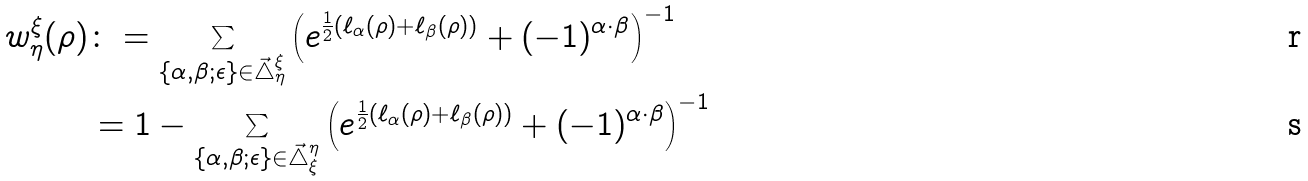<formula> <loc_0><loc_0><loc_500><loc_500>w ^ { \xi } _ { \eta } ( \rho ) & \colon = \sum _ { \{ \alpha , \beta ; \epsilon \} \in \vec { \mathcal { \triangle } } ^ { \xi } _ { \eta } } \left ( e ^ { \frac { 1 } { 2 } ( \ell _ { \alpha } ( \rho ) + \ell _ { \beta } ( \rho ) ) } + ( - 1 ) ^ { \alpha \cdot \beta } \right ) ^ { - 1 } \\ & = 1 - \sum _ { \{ \alpha , \beta ; \epsilon \} \in \vec { \mathcal { \triangle } } ^ { \eta } _ { \xi } } \left ( e ^ { \frac { 1 } { 2 } ( \ell _ { \alpha } ( \rho ) + \ell _ { \beta } ( \rho ) ) } + ( - 1 ) ^ { \alpha \cdot \beta } \right ) ^ { - 1 }</formula> 